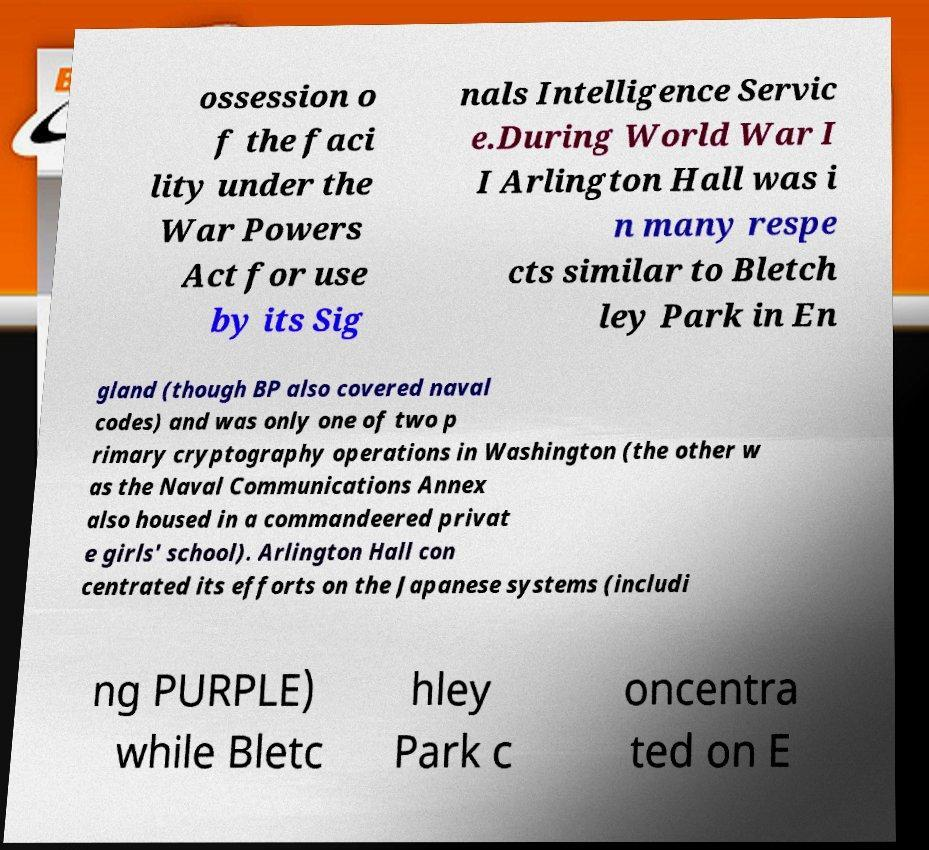For documentation purposes, I need the text within this image transcribed. Could you provide that? ossession o f the faci lity under the War Powers Act for use by its Sig nals Intelligence Servic e.During World War I I Arlington Hall was i n many respe cts similar to Bletch ley Park in En gland (though BP also covered naval codes) and was only one of two p rimary cryptography operations in Washington (the other w as the Naval Communications Annex also housed in a commandeered privat e girls' school). Arlington Hall con centrated its efforts on the Japanese systems (includi ng PURPLE) while Bletc hley Park c oncentra ted on E 